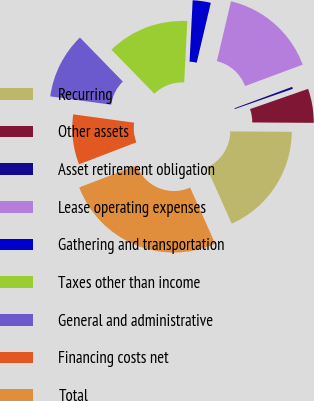<chart> <loc_0><loc_0><loc_500><loc_500><pie_chart><fcel>Recurring<fcel>Other assets<fcel>Asset retirement obligation<fcel>Lease operating expenses<fcel>Gathering and transportation<fcel>Taxes other than income<fcel>General and administrative<fcel>Financing costs net<fcel>Total<nl><fcel>18.21%<fcel>5.44%<fcel>0.33%<fcel>15.65%<fcel>2.88%<fcel>13.1%<fcel>10.54%<fcel>7.99%<fcel>25.87%<nl></chart> 